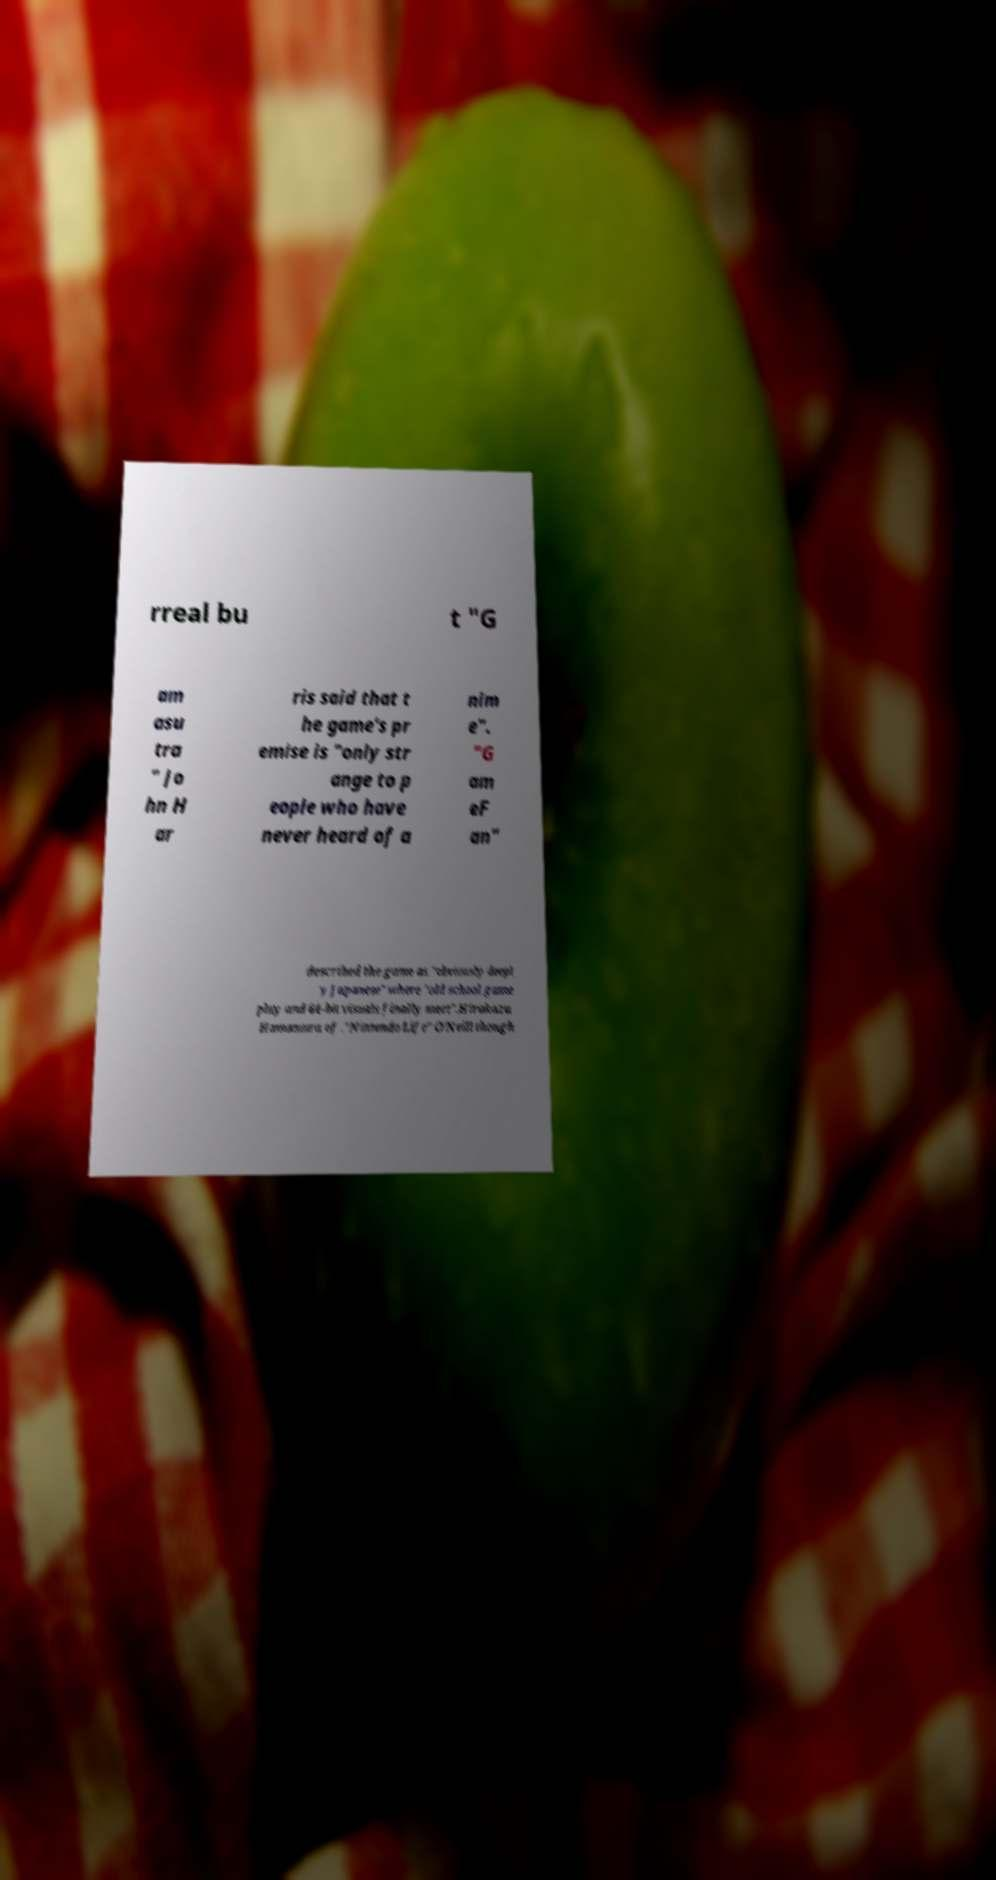Could you extract and type out the text from this image? rreal bu t "G am asu tra " Jo hn H ar ris said that t he game's pr emise is "only str ange to p eople who have never heard of a nim e". "G am eF an" described the game as "obviously deepl y Japanese" where "old school game play and 64-bit visuals finally meet".Hirokazu Hamamura of ."Nintendo Life" O'Neill though 